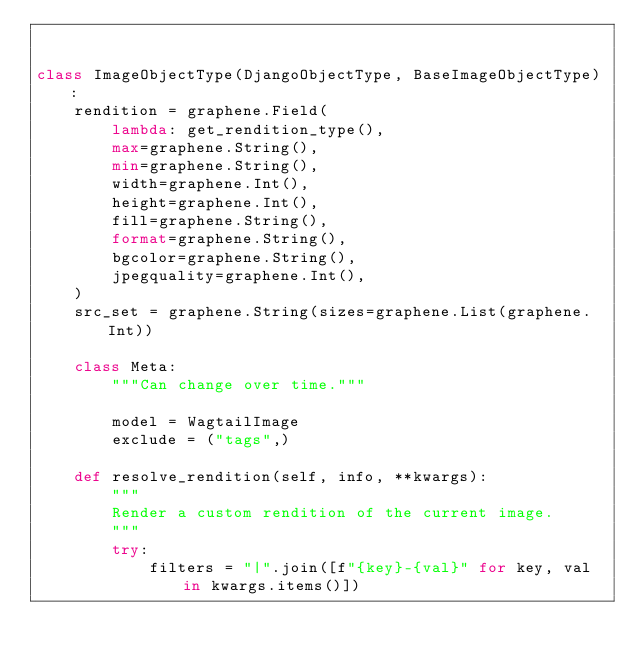<code> <loc_0><loc_0><loc_500><loc_500><_Python_>

class ImageObjectType(DjangoObjectType, BaseImageObjectType):
    rendition = graphene.Field(
        lambda: get_rendition_type(),
        max=graphene.String(),
        min=graphene.String(),
        width=graphene.Int(),
        height=graphene.Int(),
        fill=graphene.String(),
        format=graphene.String(),
        bgcolor=graphene.String(),
        jpegquality=graphene.Int(),
    )
    src_set = graphene.String(sizes=graphene.List(graphene.Int))

    class Meta:
        """Can change over time."""

        model = WagtailImage
        exclude = ("tags",)

    def resolve_rendition(self, info, **kwargs):
        """
        Render a custom rendition of the current image.
        """
        try:
            filters = "|".join([f"{key}-{val}" for key, val in kwargs.items()])</code> 